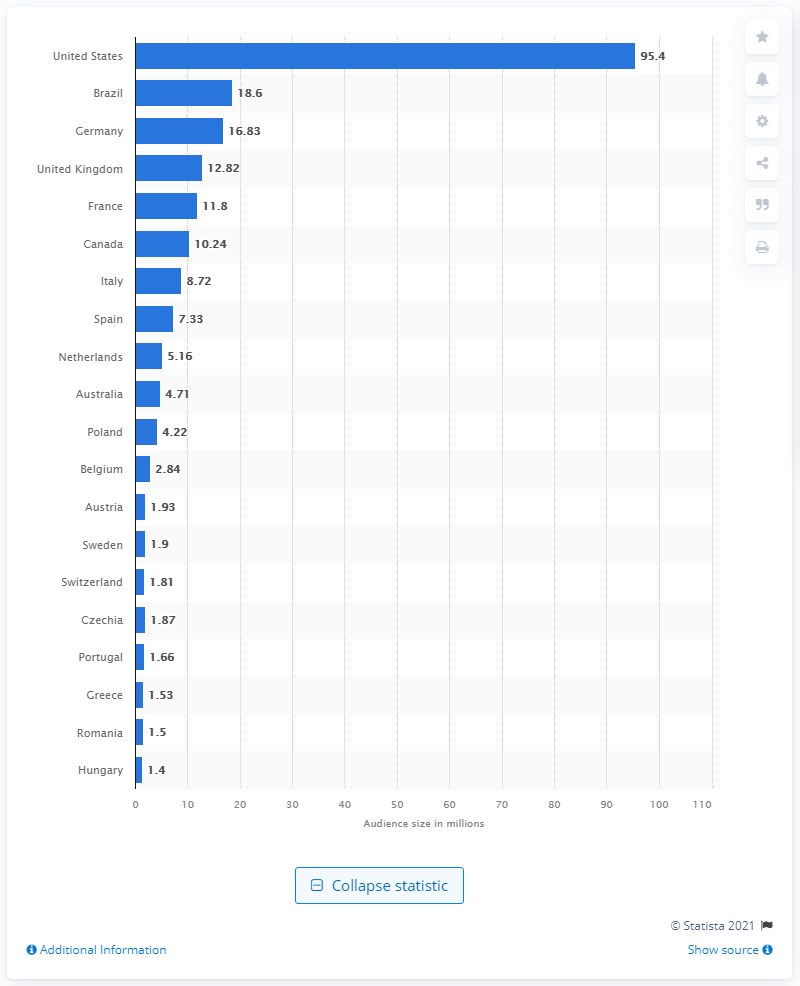Give some essential details in this illustration. As of April 2021, the audience of the United States on Pinterest was estimated to be 95.4 million. 